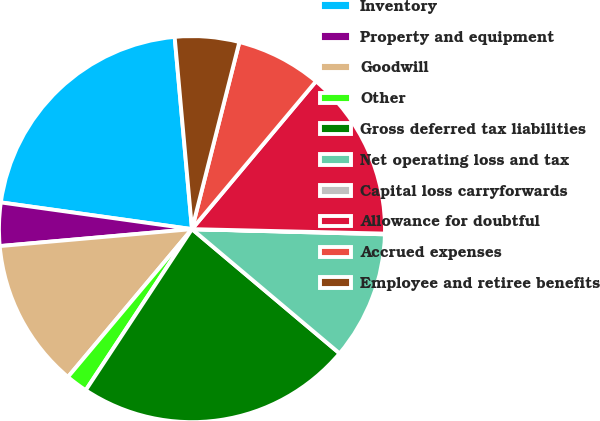Convert chart to OTSL. <chart><loc_0><loc_0><loc_500><loc_500><pie_chart><fcel>Inventory<fcel>Property and equipment<fcel>Goodwill<fcel>Other<fcel>Gross deferred tax liabilities<fcel>Net operating loss and tax<fcel>Capital loss carryforwards<fcel>Allowance for doubtful<fcel>Accrued expenses<fcel>Employee and retiree benefits<nl><fcel>21.36%<fcel>3.61%<fcel>12.49%<fcel>1.83%<fcel>23.14%<fcel>10.71%<fcel>0.06%<fcel>14.26%<fcel>7.16%<fcel>5.38%<nl></chart> 